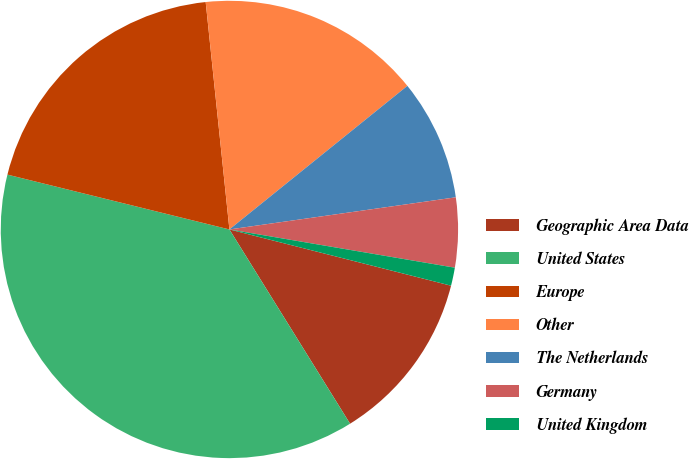<chart> <loc_0><loc_0><loc_500><loc_500><pie_chart><fcel>Geographic Area Data<fcel>United States<fcel>Europe<fcel>Other<fcel>The Netherlands<fcel>Germany<fcel>United Kingdom<nl><fcel>12.2%<fcel>37.7%<fcel>19.49%<fcel>15.85%<fcel>8.56%<fcel>4.92%<fcel>1.28%<nl></chart> 